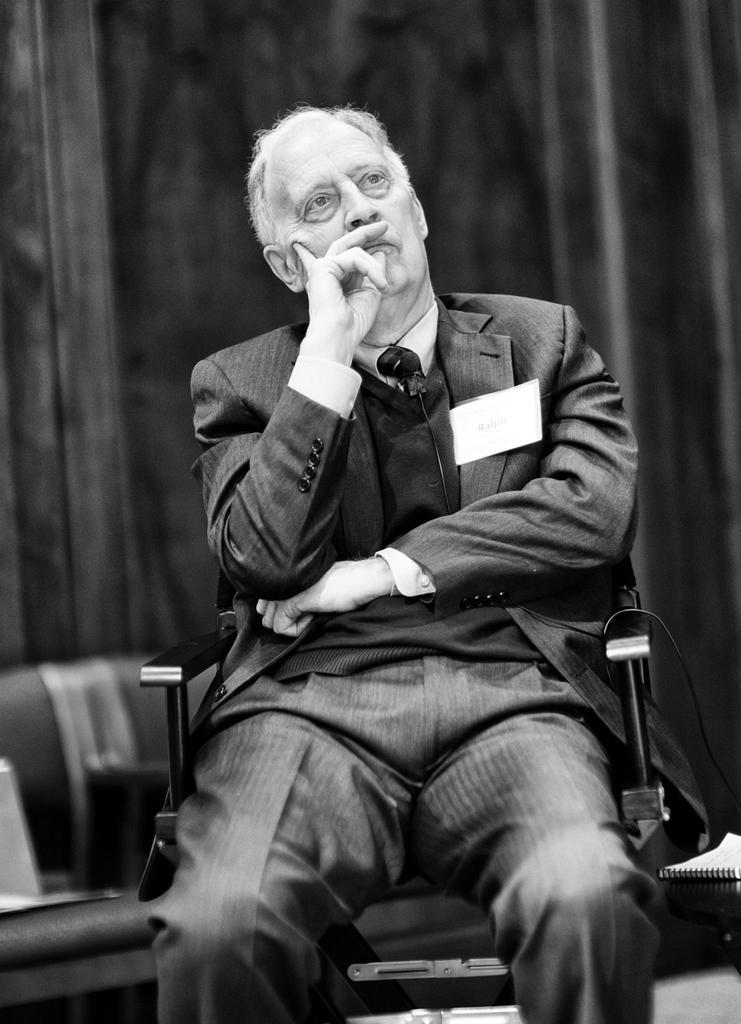What is the main subject of the image? There is a person sitting in the center of the image. What can be seen in the background of the image? There is a wall and a chair in the background of the image. How many rabbits can be seen hopping on the island in the image? There is no island or rabbits present in the image. What type of gold object is visible in the image? There is no gold object present in the image. 